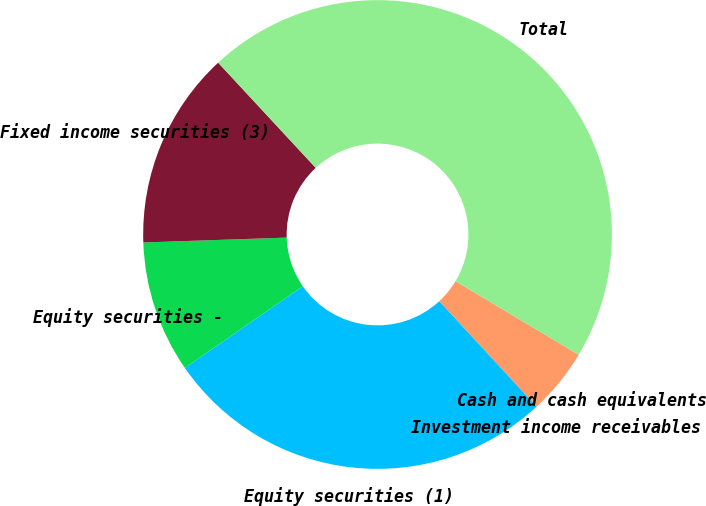Convert chart to OTSL. <chart><loc_0><loc_0><loc_500><loc_500><pie_chart><fcel>Cash and cash equivalents<fcel>Investment income receivables<fcel>Equity securities (1)<fcel>Equity securities -<fcel>Fixed income securities (3)<fcel>Total<nl><fcel>4.55%<fcel>0.0%<fcel>27.23%<fcel>9.1%<fcel>13.64%<fcel>45.48%<nl></chart> 